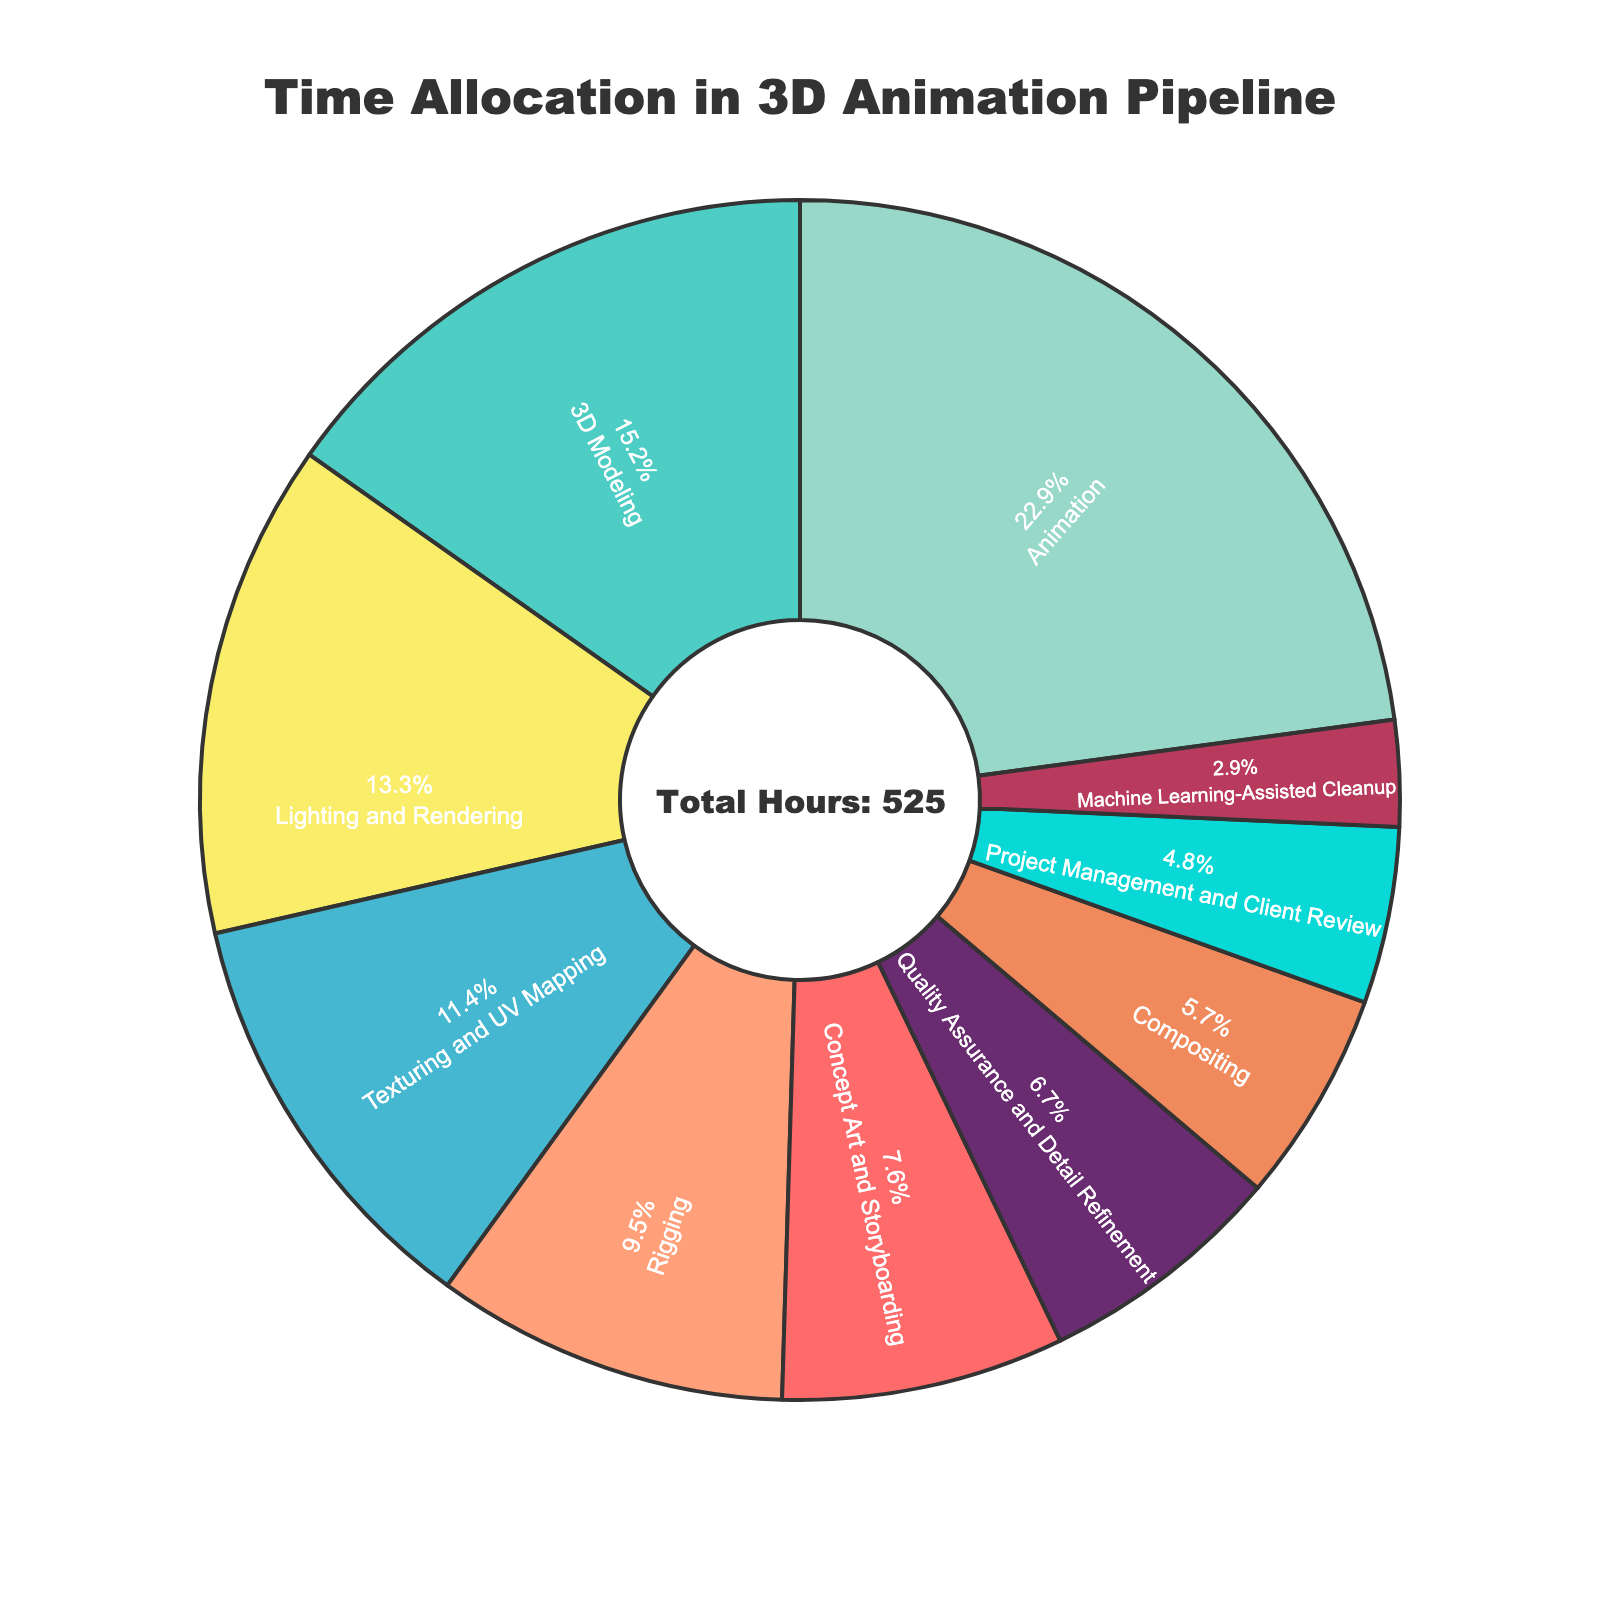What percentage of time is spent on Animation? Look at the pie chart section labeled "Animation" and note its percentage value.
Answer: 27.4% How much less time is spent on Quality Assurance and Detail Refinement compared to 3D Modeling? Find the hours for both "Quality Assurance and Detail Refinement" and "3D Modeling" from the chart, calculate the difference: 80 - 35 = 45 hours less time.
Answer: 45 hours Which stage spends the least amount of time and what is its percentage? Identify the smallest section in the pie chart, labeled "Machine Learning-Assisted Cleanup"; look at its percentage value.
Answer: Machine Learning-Assisted Cleanup, 3.4% How do the times spent on Texturing and UV Mapping and Rigging compare? Look at the chart sections for "Texturing and UV Mapping" and "Rigging", note their hours: 60 and 50, respectively. Texturing and UV Mapping has 10 more hours.
Answer: Texturing and UV Mapping has 10 more hours What is the combined percentage of time spent on Lighting and Rendering and Compositing? Add the percentages for "Lighting and Rendering" and "Compositing" from the pie chart: 16.0% + 6.9% = 22.9%.
Answer: 22.9% Which stage takes the longest time and by how much does it differ from 3D Modeling? The largest section is "Animation" with 120 hours. Compare this with "3D Modeling" (80 hours): 120 - 80 = 40 more hours.
Answer: Animation by 40 hours What is the total percentage of time spent on stages that are related to finishing touches (Quality Assurance and Detail Refinement, Project Management and Client Review, Machine Learning-Assisted Cleanup)? Add the percentages for these stages: 8.0% + 5.7% + 3.4% = 17.1%.
Answer: 17.1% What color represents Concept Art and Storyboarding? Identify the color of the chart section labeled "Concept Art and Storyboarding".
Answer: Red Which stages have a percentage close to 10%? Identify sections with percentages around 10%: "Texturing and UV Mapping" (13.7%) is closest to 10%.
Answer: Texturing and UV Mapping How many hours in total are allocated to the initial planning stages (Concept Art and Storyboarding, Project Management and Client Review)? Look at the hours for these stages: 40 for "Concept Art and Storyboarding" + 25 for "Project Management and Client Review", total is 40 + 25 = 65 hours.
Answer: 65 hours 